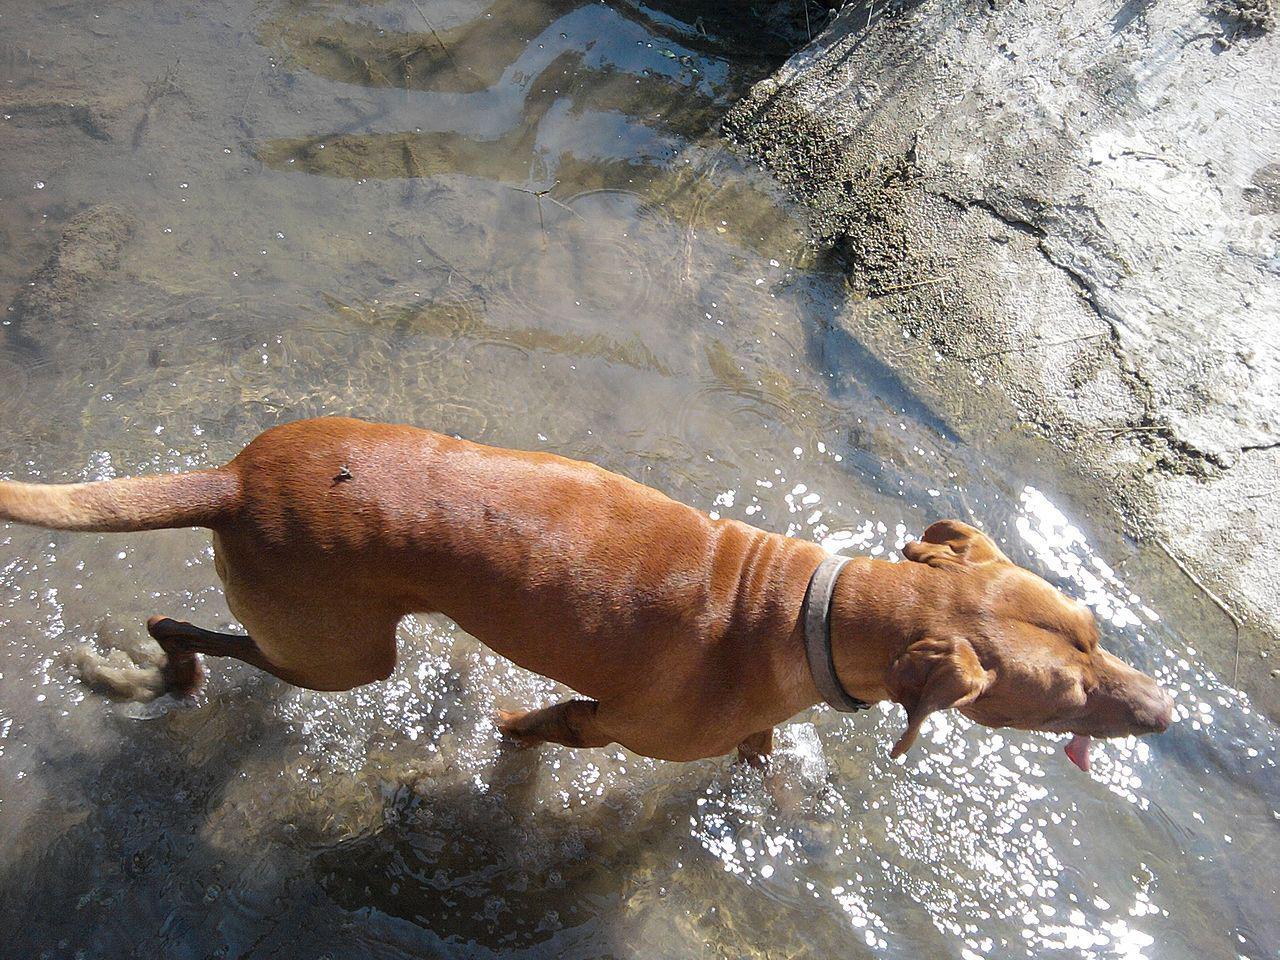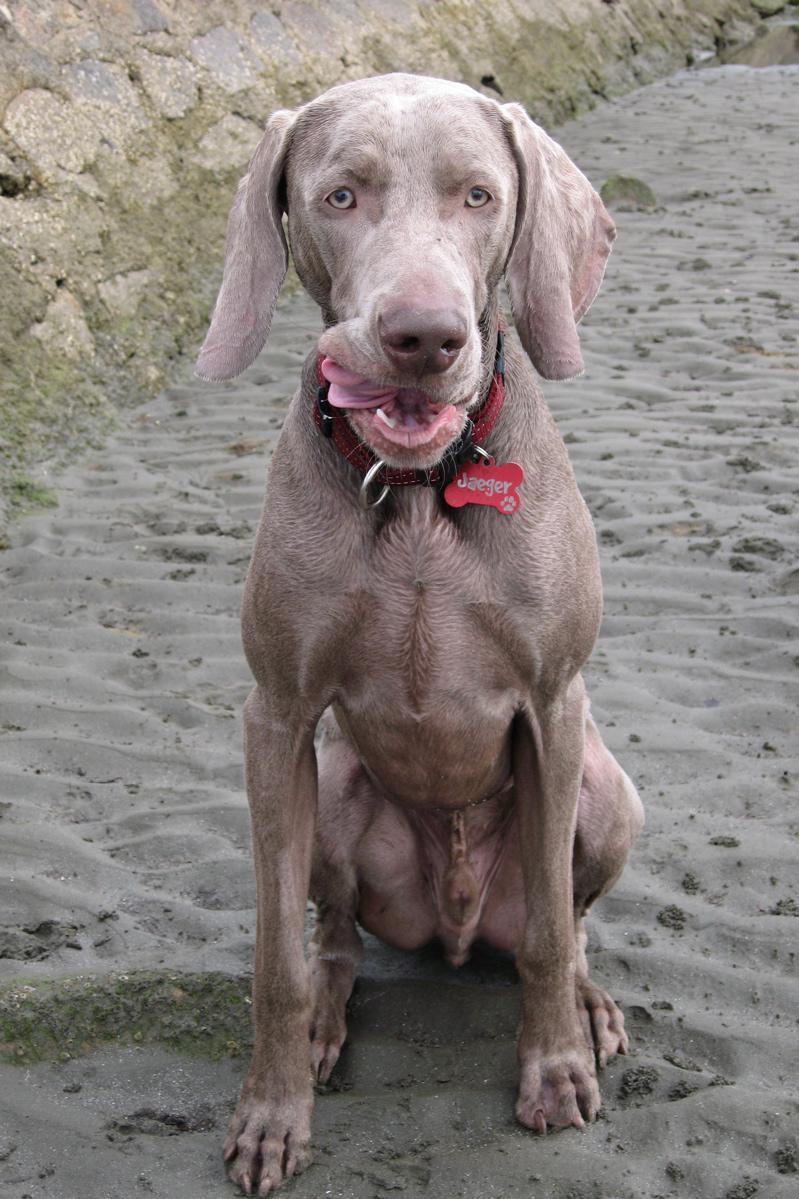The first image is the image on the left, the second image is the image on the right. Examine the images to the left and right. Is the description "The right image contains one dog that is partially submerged in water." accurate? Answer yes or no. No. 